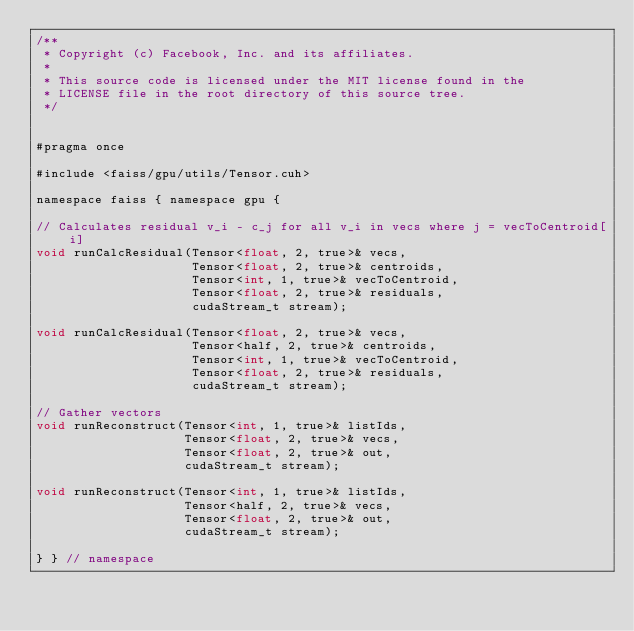Convert code to text. <code><loc_0><loc_0><loc_500><loc_500><_Cuda_>/**
 * Copyright (c) Facebook, Inc. and its affiliates.
 *
 * This source code is licensed under the MIT license found in the
 * LICENSE file in the root directory of this source tree.
 */


#pragma once

#include <faiss/gpu/utils/Tensor.cuh>

namespace faiss { namespace gpu {

// Calculates residual v_i - c_j for all v_i in vecs where j = vecToCentroid[i]
void runCalcResidual(Tensor<float, 2, true>& vecs,
                     Tensor<float, 2, true>& centroids,
                     Tensor<int, 1, true>& vecToCentroid,
                     Tensor<float, 2, true>& residuals,
                     cudaStream_t stream);

void runCalcResidual(Tensor<float, 2, true>& vecs,
                     Tensor<half, 2, true>& centroids,
                     Tensor<int, 1, true>& vecToCentroid,
                     Tensor<float, 2, true>& residuals,
                     cudaStream_t stream);

// Gather vectors
void runReconstruct(Tensor<int, 1, true>& listIds,
                    Tensor<float, 2, true>& vecs,
                    Tensor<float, 2, true>& out,
                    cudaStream_t stream);

void runReconstruct(Tensor<int, 1, true>& listIds,
                    Tensor<half, 2, true>& vecs,
                    Tensor<float, 2, true>& out,
                    cudaStream_t stream);

} } // namespace
</code> 